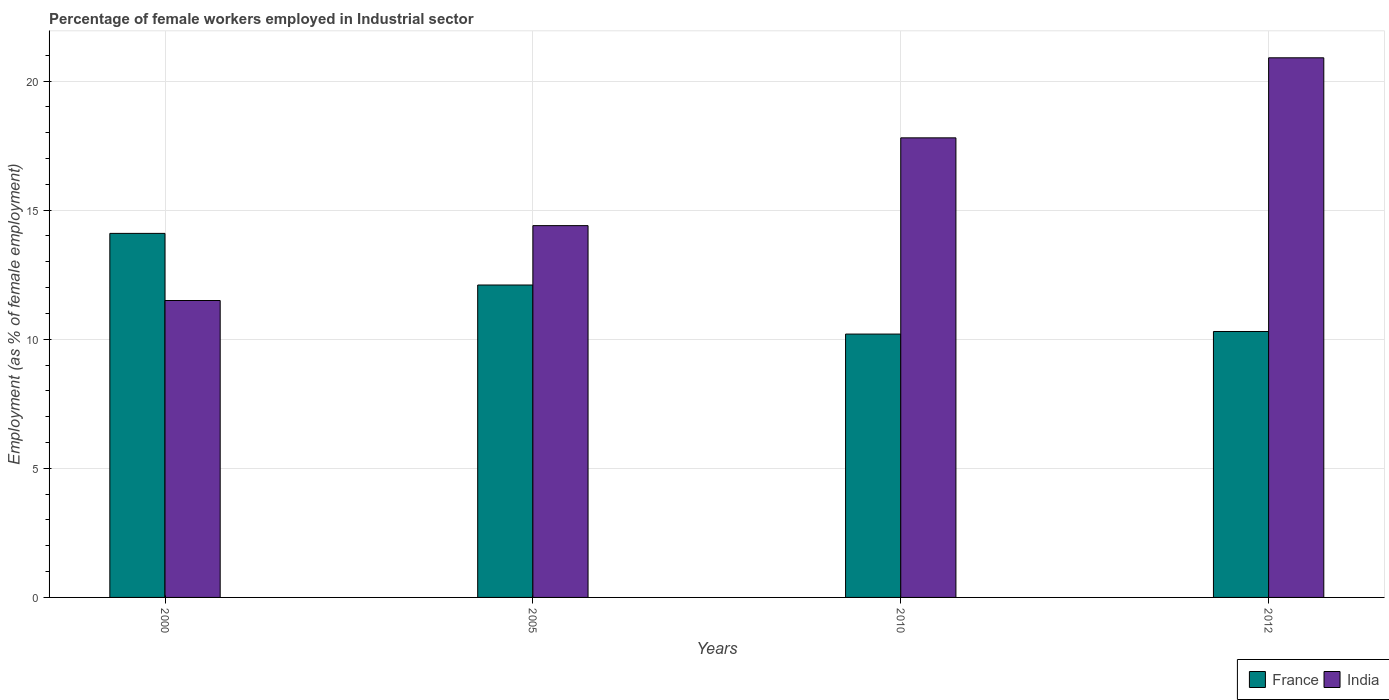How many groups of bars are there?
Provide a succinct answer. 4. Are the number of bars per tick equal to the number of legend labels?
Ensure brevity in your answer.  Yes. Are the number of bars on each tick of the X-axis equal?
Give a very brief answer. Yes. How many bars are there on the 4th tick from the left?
Your answer should be compact. 2. What is the label of the 3rd group of bars from the left?
Keep it short and to the point. 2010. What is the percentage of females employed in Industrial sector in India in 2005?
Ensure brevity in your answer.  14.4. Across all years, what is the maximum percentage of females employed in Industrial sector in India?
Make the answer very short. 20.9. Across all years, what is the minimum percentage of females employed in Industrial sector in France?
Ensure brevity in your answer.  10.2. In which year was the percentage of females employed in Industrial sector in France maximum?
Your answer should be very brief. 2000. In which year was the percentage of females employed in Industrial sector in France minimum?
Offer a terse response. 2010. What is the total percentage of females employed in Industrial sector in France in the graph?
Provide a short and direct response. 46.7. What is the difference between the percentage of females employed in Industrial sector in India in 2000 and that in 2012?
Offer a terse response. -9.4. What is the difference between the percentage of females employed in Industrial sector in India in 2000 and the percentage of females employed in Industrial sector in France in 2005?
Keep it short and to the point. -0.6. What is the average percentage of females employed in Industrial sector in India per year?
Offer a very short reply. 16.15. In the year 2005, what is the difference between the percentage of females employed in Industrial sector in India and percentage of females employed in Industrial sector in France?
Your answer should be compact. 2.3. What is the ratio of the percentage of females employed in Industrial sector in India in 2005 to that in 2012?
Your answer should be very brief. 0.69. Is the difference between the percentage of females employed in Industrial sector in India in 2010 and 2012 greater than the difference between the percentage of females employed in Industrial sector in France in 2010 and 2012?
Offer a terse response. No. What is the difference between the highest and the lowest percentage of females employed in Industrial sector in France?
Make the answer very short. 3.9. What does the 2nd bar from the left in 2010 represents?
Provide a short and direct response. India. How many bars are there?
Make the answer very short. 8. Are all the bars in the graph horizontal?
Ensure brevity in your answer.  No. How many years are there in the graph?
Provide a succinct answer. 4. Does the graph contain grids?
Offer a terse response. Yes. How many legend labels are there?
Offer a terse response. 2. How are the legend labels stacked?
Give a very brief answer. Horizontal. What is the title of the graph?
Ensure brevity in your answer.  Percentage of female workers employed in Industrial sector. Does "Fiji" appear as one of the legend labels in the graph?
Keep it short and to the point. No. What is the label or title of the Y-axis?
Offer a terse response. Employment (as % of female employment). What is the Employment (as % of female employment) of France in 2000?
Provide a short and direct response. 14.1. What is the Employment (as % of female employment) in India in 2000?
Provide a short and direct response. 11.5. What is the Employment (as % of female employment) of France in 2005?
Keep it short and to the point. 12.1. What is the Employment (as % of female employment) in India in 2005?
Provide a succinct answer. 14.4. What is the Employment (as % of female employment) of France in 2010?
Provide a succinct answer. 10.2. What is the Employment (as % of female employment) in India in 2010?
Your answer should be compact. 17.8. What is the Employment (as % of female employment) in France in 2012?
Make the answer very short. 10.3. What is the Employment (as % of female employment) in India in 2012?
Your answer should be compact. 20.9. Across all years, what is the maximum Employment (as % of female employment) of France?
Offer a very short reply. 14.1. Across all years, what is the maximum Employment (as % of female employment) in India?
Offer a very short reply. 20.9. Across all years, what is the minimum Employment (as % of female employment) of France?
Keep it short and to the point. 10.2. What is the total Employment (as % of female employment) in France in the graph?
Your answer should be compact. 46.7. What is the total Employment (as % of female employment) of India in the graph?
Your answer should be very brief. 64.6. What is the difference between the Employment (as % of female employment) of France in 2000 and that in 2005?
Make the answer very short. 2. What is the difference between the Employment (as % of female employment) of France in 2000 and that in 2012?
Your answer should be compact. 3.8. What is the difference between the Employment (as % of female employment) of India in 2000 and that in 2012?
Offer a terse response. -9.4. What is the difference between the Employment (as % of female employment) in France in 2005 and that in 2010?
Provide a short and direct response. 1.9. What is the difference between the Employment (as % of female employment) in France in 2005 and that in 2012?
Your answer should be very brief. 1.8. What is the difference between the Employment (as % of female employment) of France in 2000 and the Employment (as % of female employment) of India in 2005?
Your response must be concise. -0.3. What is the difference between the Employment (as % of female employment) of France in 2000 and the Employment (as % of female employment) of India in 2012?
Provide a succinct answer. -6.8. What is the difference between the Employment (as % of female employment) of France in 2005 and the Employment (as % of female employment) of India in 2012?
Provide a succinct answer. -8.8. What is the average Employment (as % of female employment) of France per year?
Provide a succinct answer. 11.68. What is the average Employment (as % of female employment) of India per year?
Your answer should be compact. 16.15. In the year 2005, what is the difference between the Employment (as % of female employment) of France and Employment (as % of female employment) of India?
Your answer should be compact. -2.3. In the year 2010, what is the difference between the Employment (as % of female employment) in France and Employment (as % of female employment) in India?
Give a very brief answer. -7.6. What is the ratio of the Employment (as % of female employment) in France in 2000 to that in 2005?
Your response must be concise. 1.17. What is the ratio of the Employment (as % of female employment) in India in 2000 to that in 2005?
Make the answer very short. 0.8. What is the ratio of the Employment (as % of female employment) of France in 2000 to that in 2010?
Keep it short and to the point. 1.38. What is the ratio of the Employment (as % of female employment) of India in 2000 to that in 2010?
Offer a terse response. 0.65. What is the ratio of the Employment (as % of female employment) of France in 2000 to that in 2012?
Offer a very short reply. 1.37. What is the ratio of the Employment (as % of female employment) in India in 2000 to that in 2012?
Offer a terse response. 0.55. What is the ratio of the Employment (as % of female employment) in France in 2005 to that in 2010?
Keep it short and to the point. 1.19. What is the ratio of the Employment (as % of female employment) of India in 2005 to that in 2010?
Ensure brevity in your answer.  0.81. What is the ratio of the Employment (as % of female employment) of France in 2005 to that in 2012?
Your answer should be compact. 1.17. What is the ratio of the Employment (as % of female employment) of India in 2005 to that in 2012?
Make the answer very short. 0.69. What is the ratio of the Employment (as % of female employment) of France in 2010 to that in 2012?
Give a very brief answer. 0.99. What is the ratio of the Employment (as % of female employment) of India in 2010 to that in 2012?
Offer a terse response. 0.85. What is the difference between the highest and the second highest Employment (as % of female employment) of India?
Your response must be concise. 3.1. What is the difference between the highest and the lowest Employment (as % of female employment) of France?
Offer a terse response. 3.9. 